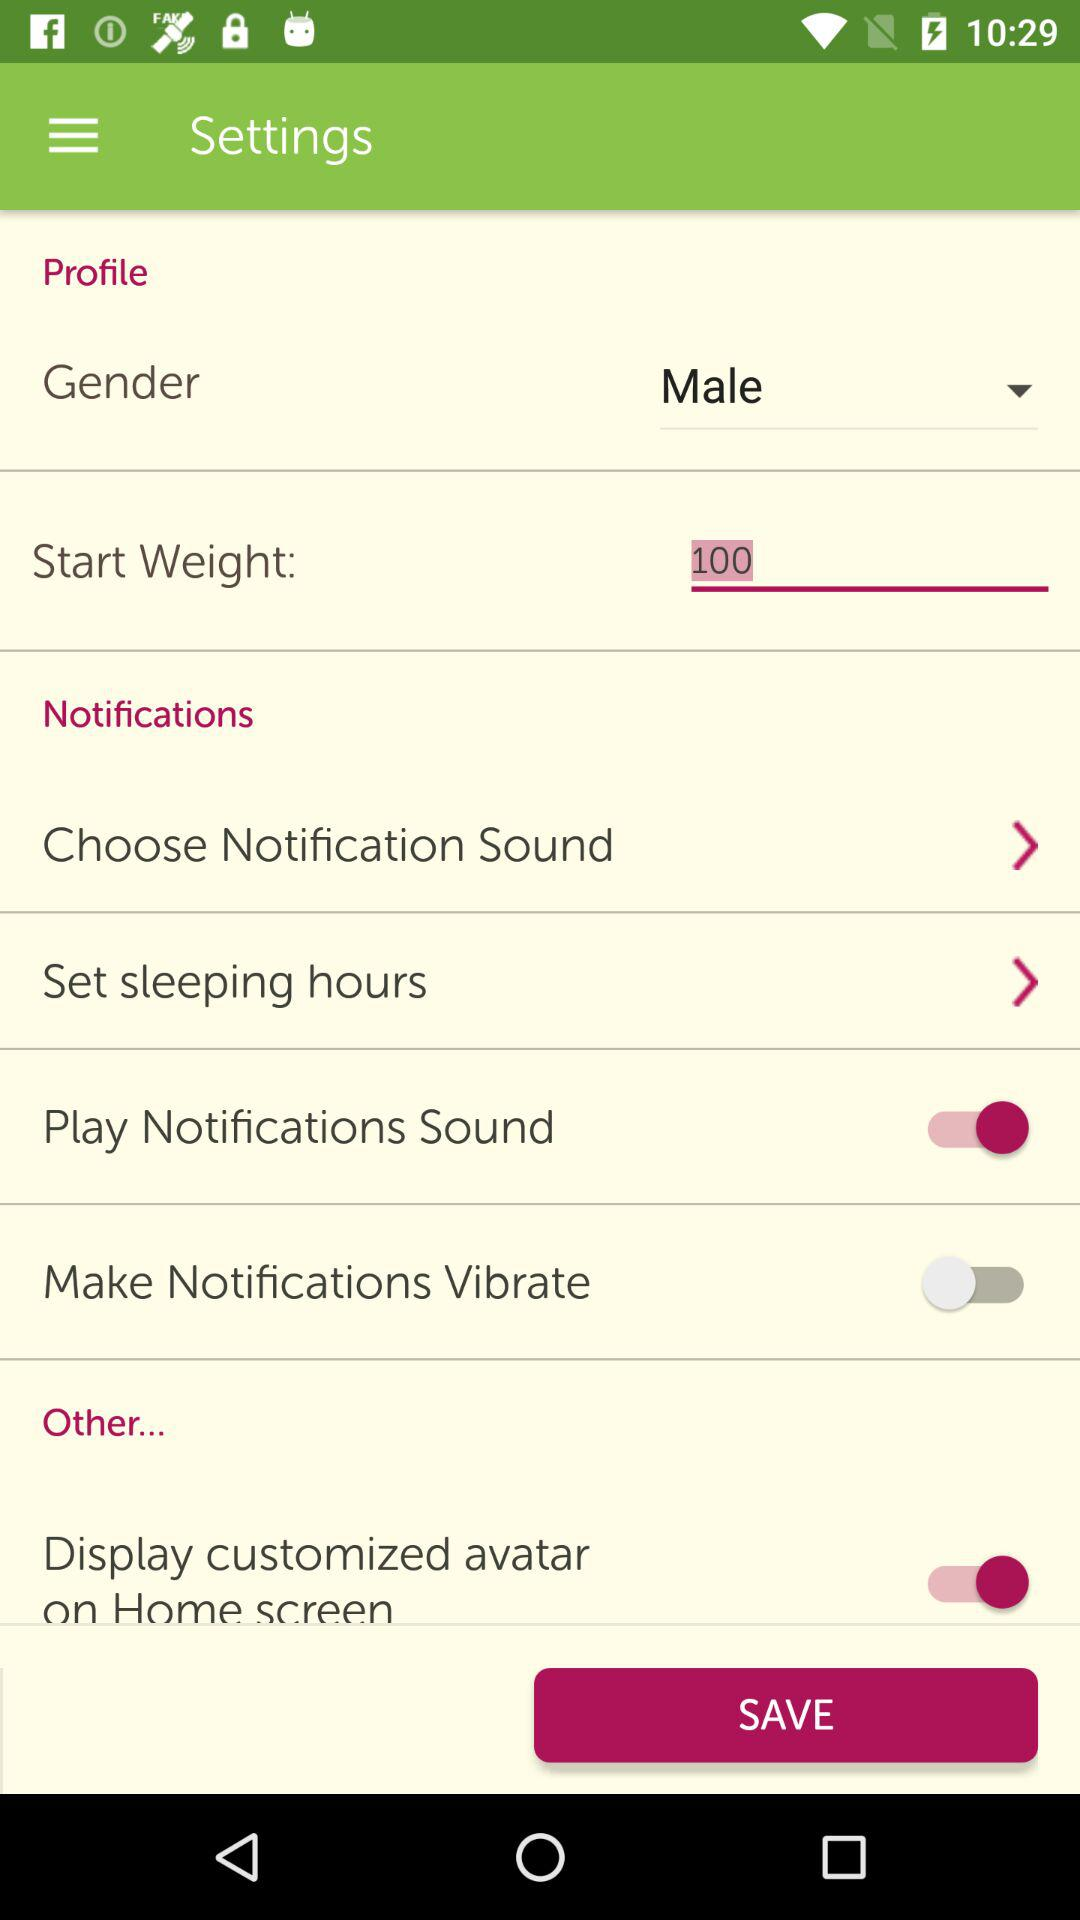What is the status of the "Display customized avatar on Home screen"? The status is "on". 